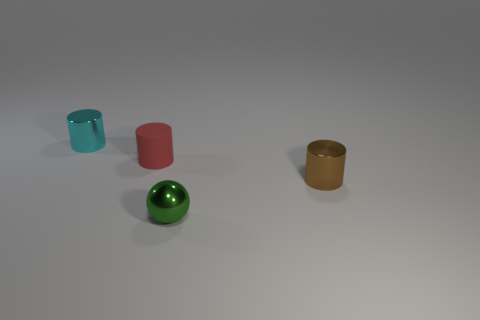Subtract all brown cylinders. How many cylinders are left? 2 Subtract all tiny metallic cylinders. How many cylinders are left? 1 Subtract all spheres. How many objects are left? 3 Subtract 0 red blocks. How many objects are left? 4 Subtract 3 cylinders. How many cylinders are left? 0 Subtract all yellow cylinders. Subtract all gray blocks. How many cylinders are left? 3 Subtract all red balls. How many purple cylinders are left? 0 Subtract all red rubber objects. Subtract all tiny cyan shiny things. How many objects are left? 2 Add 1 small cyan cylinders. How many small cyan cylinders are left? 2 Add 4 red matte cylinders. How many red matte cylinders exist? 5 